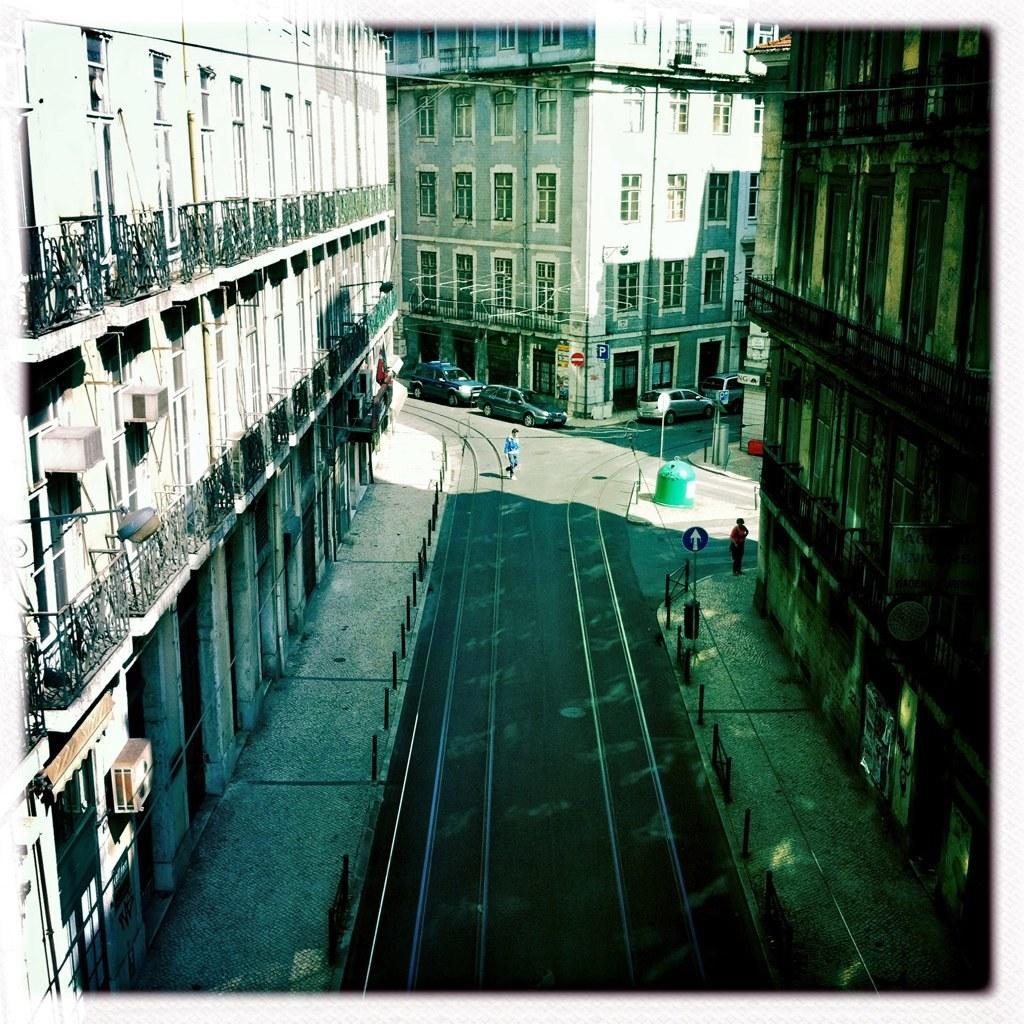Could you give a brief overview of what you see in this image? In this image there is a person walking on the road and there is another person walking on the pavement and there are a few cars parked on the road, on the road there are sign boards and lamp posts, besides the roads there are buildings with metal balconies. 